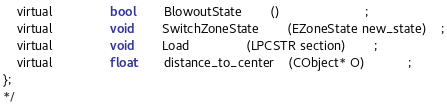<code> <loc_0><loc_0><loc_500><loc_500><_C_>	virtual				bool		BlowoutState		()						;
	virtual				void		SwitchZoneState		(EZoneState new_state)	;
	virtual				void		Load				(LPCSTR section)		;
	virtual				float		distance_to_center	(CObject* O)			;	
};
*/</code> 